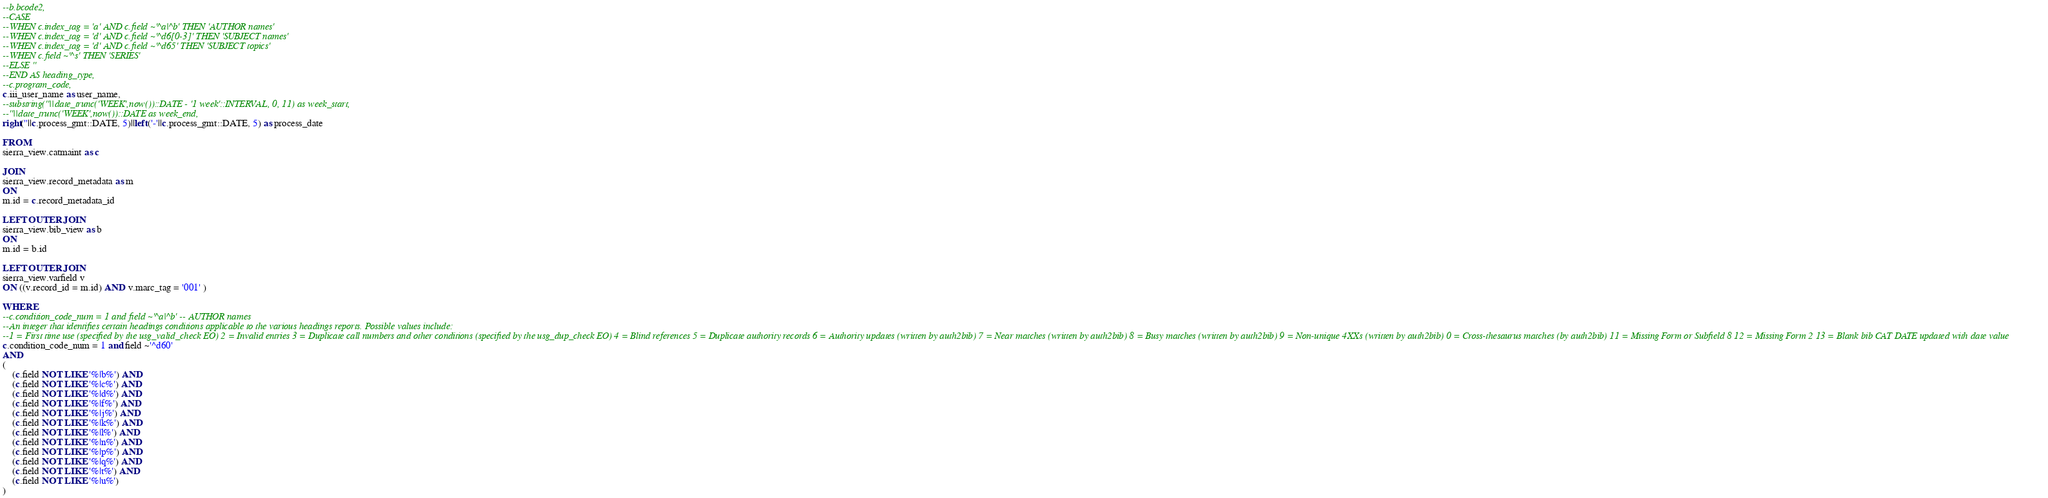Convert code to text. <code><loc_0><loc_0><loc_500><loc_500><_SQL_>--b.bcode2,
--CASE
--WHEN c.index_tag = 'a' AND c.field ~'^a|^b' THEN 'AUTHOR names'
--WHEN c.index_tag = 'd' AND c.field ~'^d6[0-3]' THEN 'SUBJECT names'
--WHEN c.index_tag = 'd' AND c.field ~'^d65' THEN 'SUBJECT topics'
--WHEN c.field ~'^s' THEN 'SERIES'
--ELSE ''
--END AS heading_type,
--c.program_code,
c.iii_user_name as user_name,
--substring(''||date_trunc('WEEK',now())::DATE - '1 week'::INTERVAL, 0, 11) as week_start,
--''||date_trunc('WEEK',now())::DATE as week_end,
right(''||c.process_gmt::DATE, 5)||left('-'||c.process_gmt::DATE, 5) as process_date

FROM
sierra_view.catmaint as c

JOIN
sierra_view.record_metadata as m
ON
m.id = c.record_metadata_id

LEFT OUTER JOIN
sierra_view.bib_view as b
ON
m.id = b.id

LEFT OUTER JOIN
sierra_view.varfield v
ON ((v.record_id = m.id) AND v.marc_tag = '001' )

WHERE
--c.condition_code_num = 1 and field ~'^a|^b' -- AUTHOR names
--An integer that identifies certain headings conditions applicable to the various headings reports. Possible values include: 
--1 = First time use (specified by the usg_valid_check EO) 2 = Invalid entries 3 = Duplicate call numbers and other conditions (specified by the usg_dup_check EO) 4 = Blind references 5 = Duplicate authority records 6 = Authority updates (written by auth2bib) 7 = Near matches (written by auth2bib) 8 = Busy matches (written by auth2bib) 9 = Non-unique 4XXs (written by auth2bib) 0 = Cross-thesaurus matches (by auth2bib) 11 = Missing Form or Subfield 8 12 = Missing Form 2 13 = Blank bib CAT DATE updated with date value 
c.condition_code_num = 1 and field ~'^d60'
AND 
(
    (c.field NOT LIKE '%|b%') AND
    (c.field NOT LIKE '%|c%') AND
    (c.field NOT LIKE '%|d%') AND
    (c.field NOT LIKE '%|f%') AND
    (c.field NOT LIKE '%|j%') AND
    (c.field NOT LIKE '%|k%') AND
    (c.field NOT LIKE '%|l%') AND
    (c.field NOT LIKE '%|n%') AND
    (c.field NOT LIKE '%|p%') AND
    (c.field NOT LIKE '%|q%') AND
    (c.field NOT LIKE '%|t%') AND
    (c.field NOT LIKE '%|u%')
)</code> 